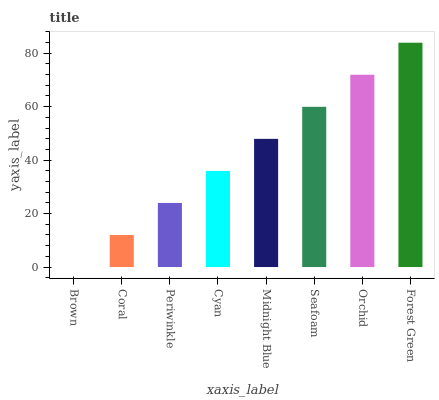Is Brown the minimum?
Answer yes or no. Yes. Is Forest Green the maximum?
Answer yes or no. Yes. Is Coral the minimum?
Answer yes or no. No. Is Coral the maximum?
Answer yes or no. No. Is Coral greater than Brown?
Answer yes or no. Yes. Is Brown less than Coral?
Answer yes or no. Yes. Is Brown greater than Coral?
Answer yes or no. No. Is Coral less than Brown?
Answer yes or no. No. Is Midnight Blue the high median?
Answer yes or no. Yes. Is Cyan the low median?
Answer yes or no. Yes. Is Seafoam the high median?
Answer yes or no. No. Is Periwinkle the low median?
Answer yes or no. No. 